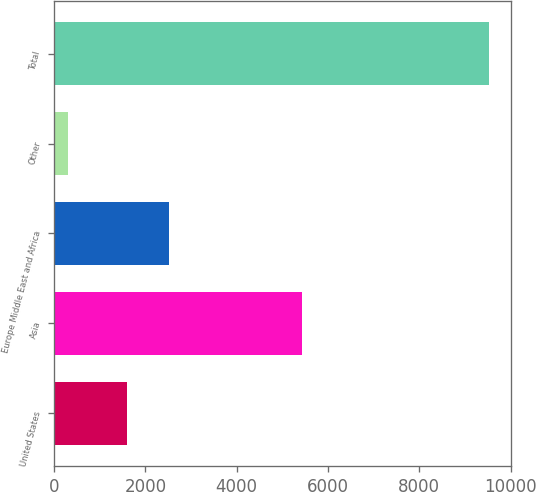Convert chart. <chart><loc_0><loc_0><loc_500><loc_500><bar_chart><fcel>United States<fcel>Asia<fcel>Europe Middle East and Africa<fcel>Other<fcel>Total<nl><fcel>1589<fcel>5434<fcel>2510.9<fcel>307<fcel>9526<nl></chart> 